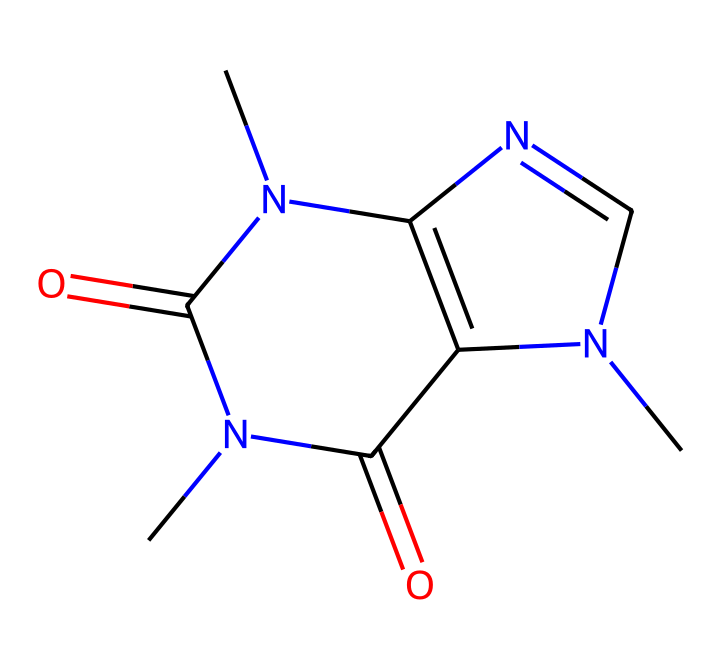What is the molecular formula of caffeine? To determine the molecular formula, we count the number of each type of atom in the structure derived from the SMILES notation. There are 8 carbon atoms (C), 10 hydrogen atoms (H), 4 nitrogen atoms (N), and 2 oxygen atoms (O). Therefore, the molecular formula is C8H10N4O2.
Answer: C8H10N4O2 How many chiral centers are in this caffeine molecule? A chiral center is defined as a carbon atom bonded to four different groups. By examining the structure derived from the SMILES representation, we find that there are no carbon atoms meeting this criteria; thus, caffeine does not exhibit chirality.
Answer: 0 What type of compound is caffeine classified as? Caffeine has nitrogen-containing heterocycles in its structure, characteristic of alkaloids. Alkaloids are organic compounds primarily derived from plants and often have pronounced pharmacological effects. Since caffeine fits this description, it is classified as an alkaloid.
Answer: alkaloid Is caffeine a stimulant or a depressant? Caffeine is known for its stimulating effects in the central nervous system, which enhances alertness and reduces fatigue. This indicates that it is classified as a stimulant.
Answer: stimulant What functional groups are present in caffeine? Analyzing the structure from the SMILES, we find that caffeine contains amine groups (due to nitrogen atoms bonded to carbon) and carbonyl groups (the carbon atoms double-bonded to oxygen). These functional groups play a critical role in caffeine’s biological activity.
Answer: amine, carbonyl What property does caffeine impart that facilitates creativity? Caffeine is well-known to increase alertness and cognitive function, which can contribute to improved focus and creativity. This stimulating effect is primarily due to its ability to block adenosine receptors in the brain.
Answer: alertness 